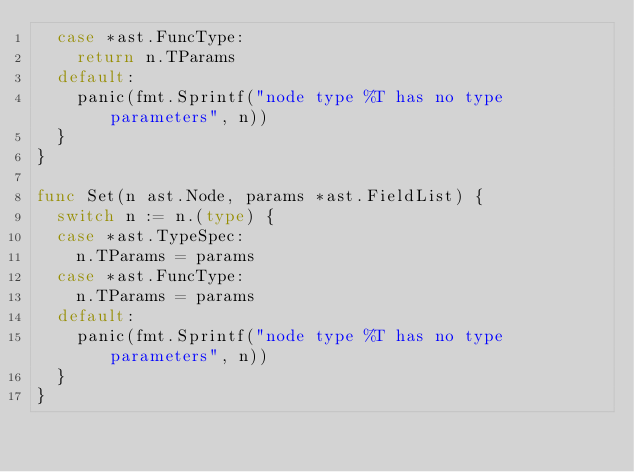<code> <loc_0><loc_0><loc_500><loc_500><_Go_>	case *ast.FuncType:
		return n.TParams
	default:
		panic(fmt.Sprintf("node type %T has no type parameters", n))
	}
}

func Set(n ast.Node, params *ast.FieldList) {
	switch n := n.(type) {
	case *ast.TypeSpec:
		n.TParams = params
	case *ast.FuncType:
		n.TParams = params
	default:
		panic(fmt.Sprintf("node type %T has no type parameters", n))
	}
}
</code> 